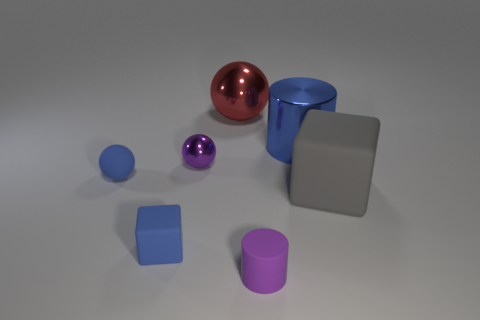Subtract all tiny blue spheres. How many spheres are left? 2 Add 2 big blue rubber things. How many objects exist? 9 Subtract all gray blocks. How many blocks are left? 1 Subtract 1 balls. How many balls are left? 2 Subtract all brown blocks. How many purple cylinders are left? 1 Subtract all big shiny cylinders. Subtract all big gray blocks. How many objects are left? 5 Add 4 large blue objects. How many large blue objects are left? 5 Add 5 metallic cubes. How many metallic cubes exist? 5 Subtract 0 green cylinders. How many objects are left? 7 Subtract all cylinders. How many objects are left? 5 